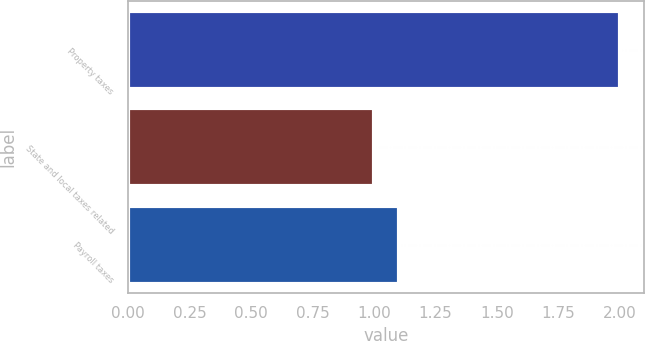Convert chart. <chart><loc_0><loc_0><loc_500><loc_500><bar_chart><fcel>Property taxes<fcel>State and local taxes related<fcel>Payroll taxes<nl><fcel>2<fcel>1<fcel>1.1<nl></chart> 